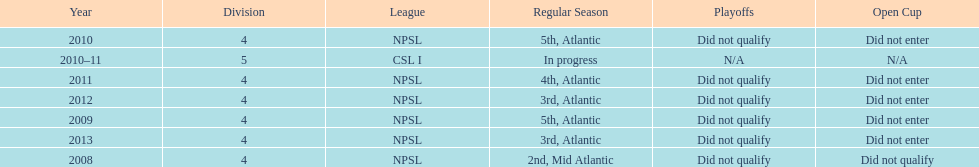How did they place the year after they were 4th in the regular season? 3rd. Give me the full table as a dictionary. {'header': ['Year', 'Division', 'League', 'Regular Season', 'Playoffs', 'Open Cup'], 'rows': [['2010', '4', 'NPSL', '5th, Atlantic', 'Did not qualify', 'Did not enter'], ['2010–11', '5', 'CSL I', 'In progress', 'N/A', 'N/A'], ['2011', '4', 'NPSL', '4th, Atlantic', 'Did not qualify', 'Did not enter'], ['2012', '4', 'NPSL', '3rd, Atlantic', 'Did not qualify', 'Did not enter'], ['2009', '4', 'NPSL', '5th, Atlantic', 'Did not qualify', 'Did not enter'], ['2013', '4', 'NPSL', '3rd, Atlantic', 'Did not qualify', 'Did not enter'], ['2008', '4', 'NPSL', '2nd, Mid Atlantic', 'Did not qualify', 'Did not qualify']]} 